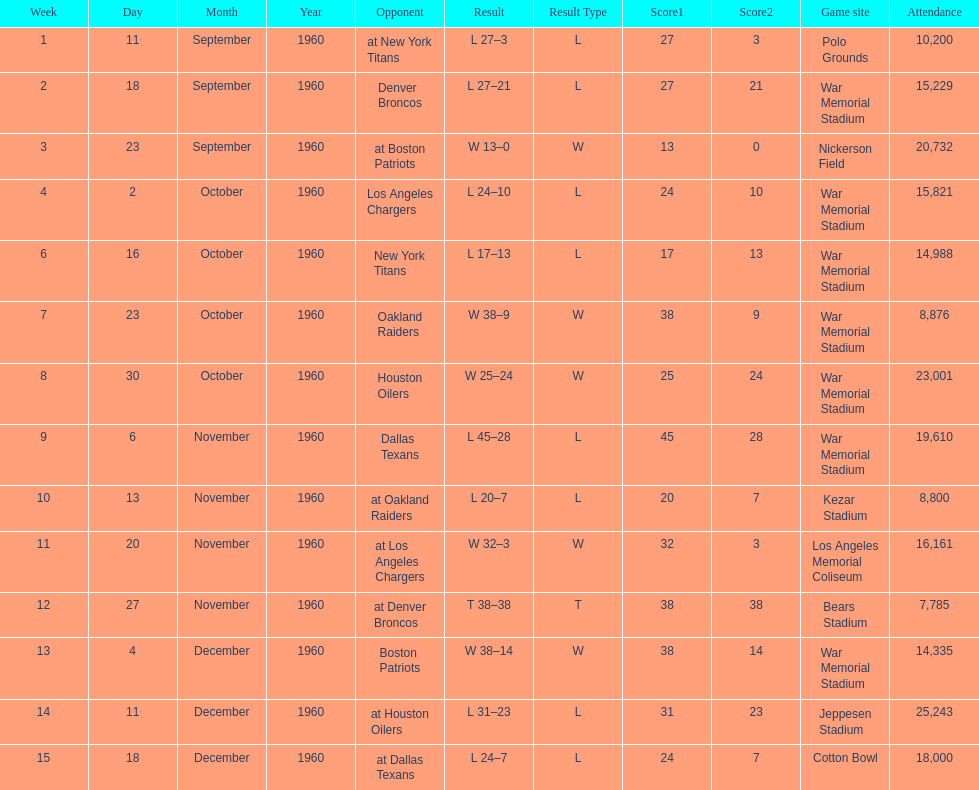How many times was war memorial stadium the game site? 6. 